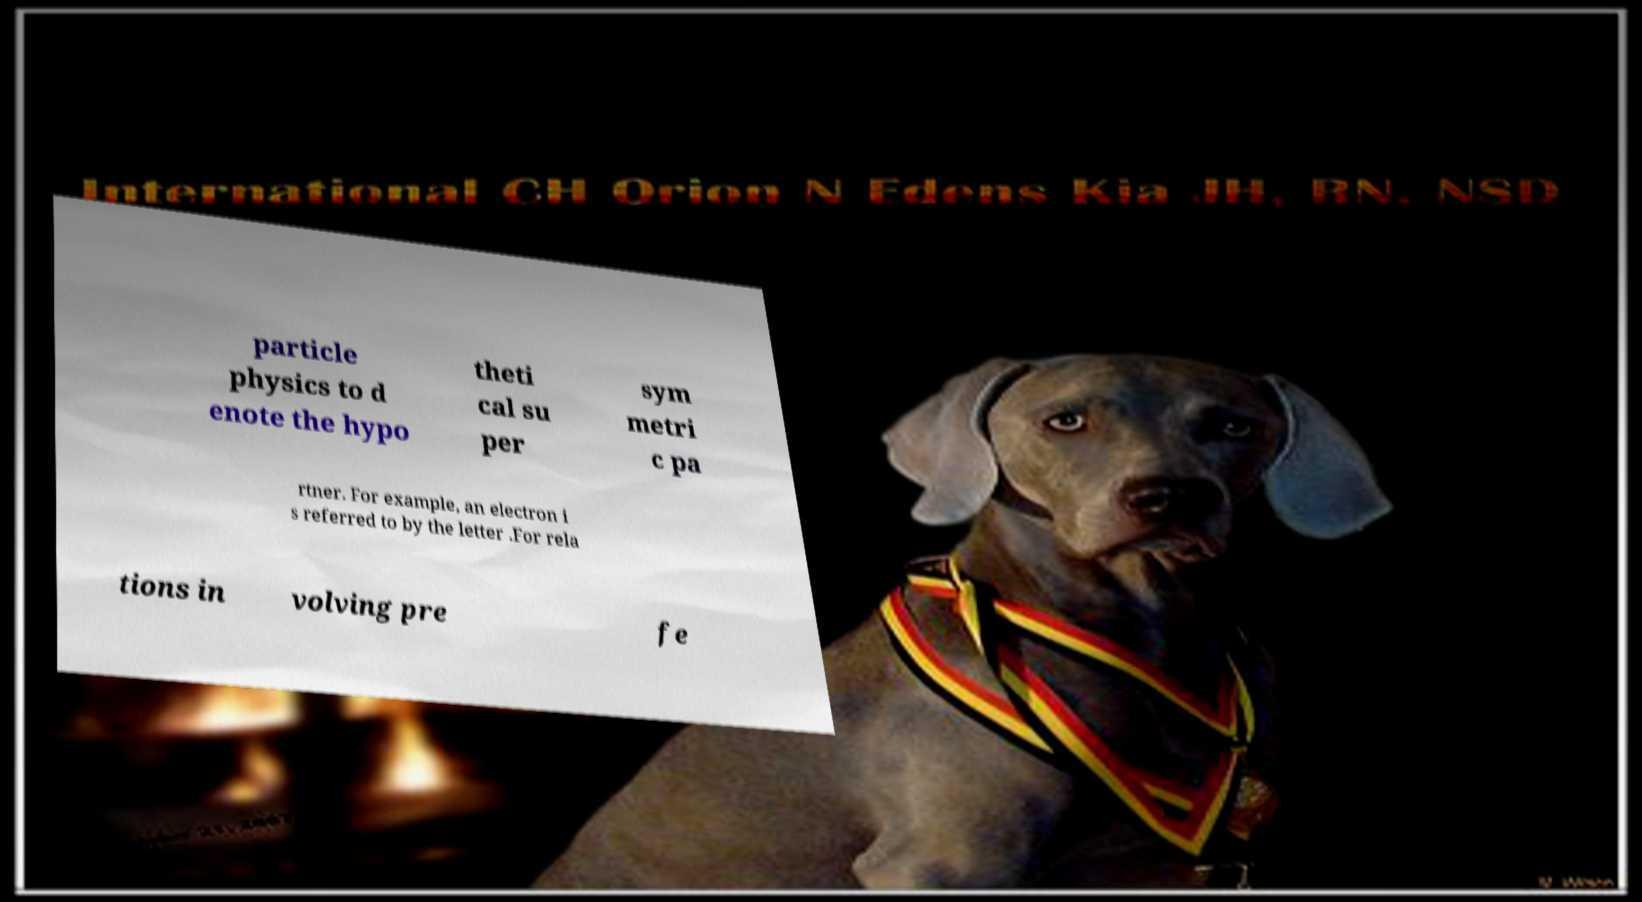Can you read and provide the text displayed in the image?This photo seems to have some interesting text. Can you extract and type it out for me? particle physics to d enote the hypo theti cal su per sym metri c pa rtner. For example, an electron i s referred to by the letter .For rela tions in volving pre fe 